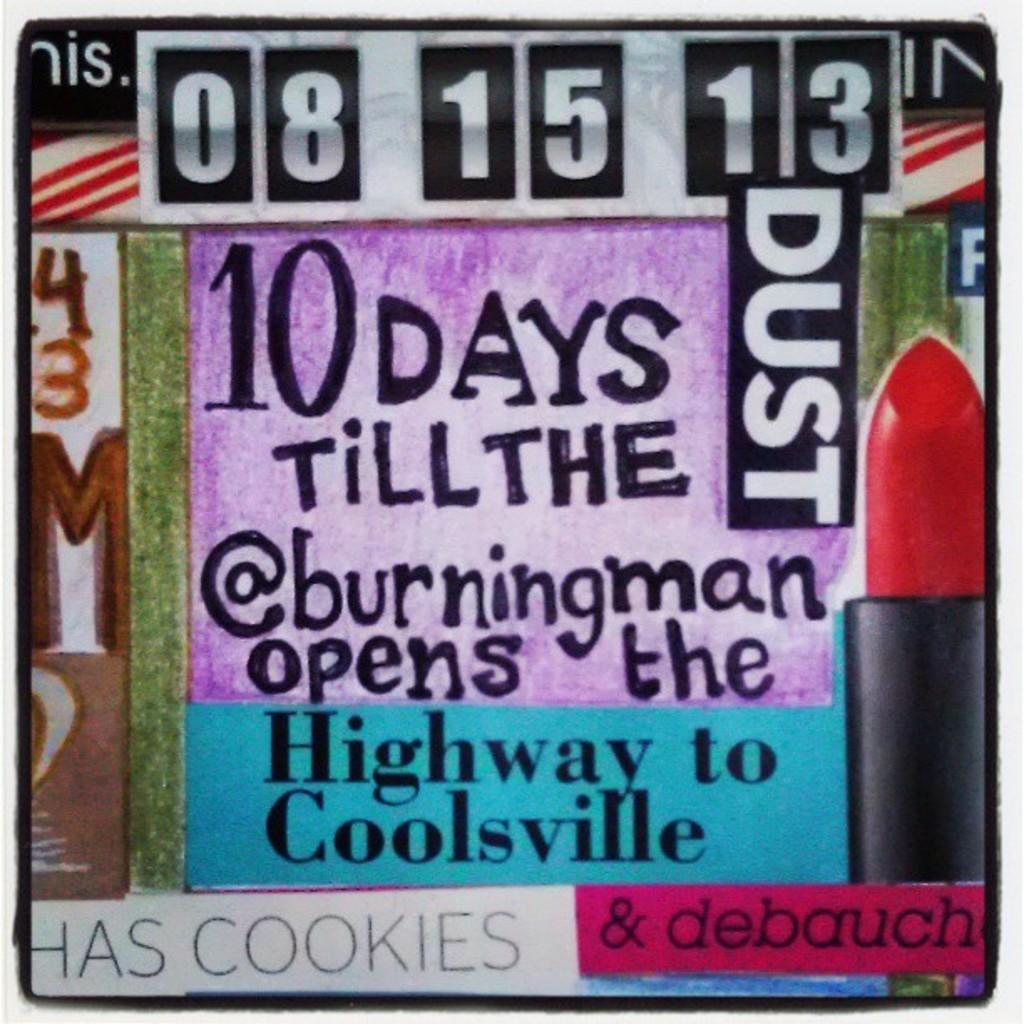What is present on the poster in the image? There is a poster in the image, and it contains text. Can you describe the content of the poster? The poster contains text, but the specific content cannot be determined from the image alone. What type of hammer can be seen in the image? There is no hammer present in the image. What color is the hair on the poster in the image? There is no hair depicted on the poster in the image. 